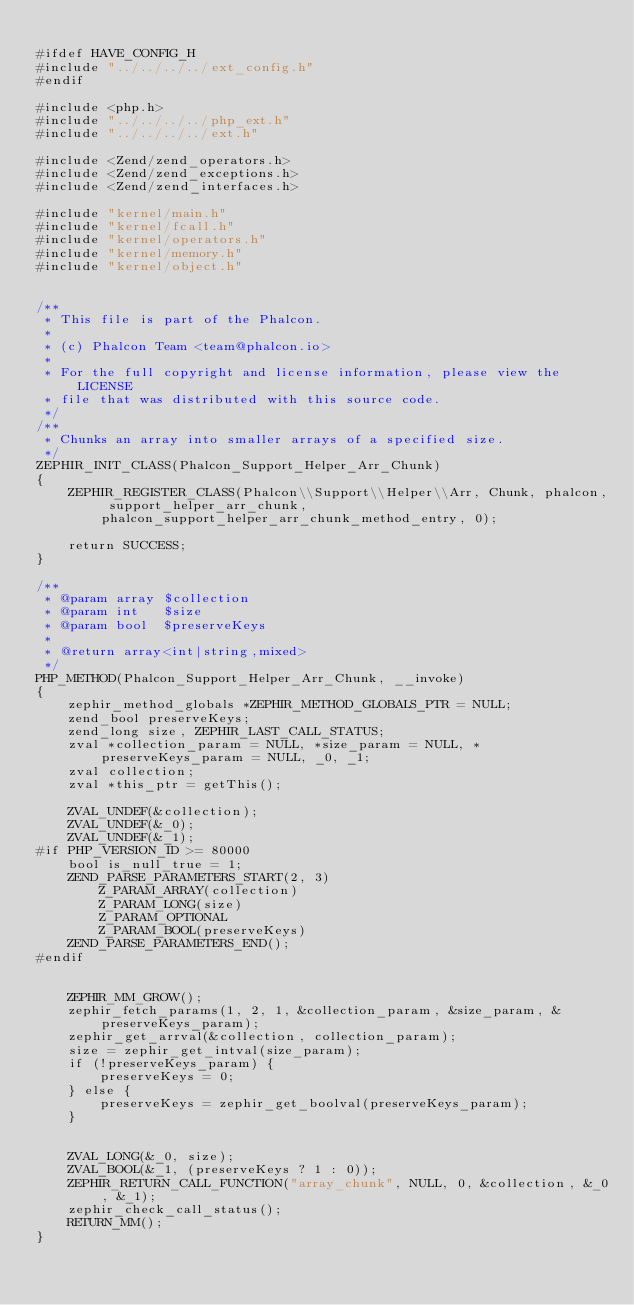Convert code to text. <code><loc_0><loc_0><loc_500><loc_500><_C_>
#ifdef HAVE_CONFIG_H
#include "../../../../ext_config.h"
#endif

#include <php.h>
#include "../../../../php_ext.h"
#include "../../../../ext.h"

#include <Zend/zend_operators.h>
#include <Zend/zend_exceptions.h>
#include <Zend/zend_interfaces.h>

#include "kernel/main.h"
#include "kernel/fcall.h"
#include "kernel/operators.h"
#include "kernel/memory.h"
#include "kernel/object.h"


/**
 * This file is part of the Phalcon.
 *
 * (c) Phalcon Team <team@phalcon.io>
 *
 * For the full copyright and license information, please view the LICENSE
 * file that was distributed with this source code.
 */
/**
 * Chunks an array into smaller arrays of a specified size.
 */
ZEPHIR_INIT_CLASS(Phalcon_Support_Helper_Arr_Chunk)
{
	ZEPHIR_REGISTER_CLASS(Phalcon\\Support\\Helper\\Arr, Chunk, phalcon, support_helper_arr_chunk, phalcon_support_helper_arr_chunk_method_entry, 0);

	return SUCCESS;
}

/**
 * @param array $collection
 * @param int   $size
 * @param bool  $preserveKeys
 *
 * @return array<int|string,mixed>
 */
PHP_METHOD(Phalcon_Support_Helper_Arr_Chunk, __invoke)
{
	zephir_method_globals *ZEPHIR_METHOD_GLOBALS_PTR = NULL;
	zend_bool preserveKeys;
	zend_long size, ZEPHIR_LAST_CALL_STATUS;
	zval *collection_param = NULL, *size_param = NULL, *preserveKeys_param = NULL, _0, _1;
	zval collection;
	zval *this_ptr = getThis();

	ZVAL_UNDEF(&collection);
	ZVAL_UNDEF(&_0);
	ZVAL_UNDEF(&_1);
#if PHP_VERSION_ID >= 80000
	bool is_null_true = 1;
	ZEND_PARSE_PARAMETERS_START(2, 3)
		Z_PARAM_ARRAY(collection)
		Z_PARAM_LONG(size)
		Z_PARAM_OPTIONAL
		Z_PARAM_BOOL(preserveKeys)
	ZEND_PARSE_PARAMETERS_END();
#endif


	ZEPHIR_MM_GROW();
	zephir_fetch_params(1, 2, 1, &collection_param, &size_param, &preserveKeys_param);
	zephir_get_arrval(&collection, collection_param);
	size = zephir_get_intval(size_param);
	if (!preserveKeys_param) {
		preserveKeys = 0;
	} else {
		preserveKeys = zephir_get_boolval(preserveKeys_param);
	}


	ZVAL_LONG(&_0, size);
	ZVAL_BOOL(&_1, (preserveKeys ? 1 : 0));
	ZEPHIR_RETURN_CALL_FUNCTION("array_chunk", NULL, 0, &collection, &_0, &_1);
	zephir_check_call_status();
	RETURN_MM();
}

</code> 